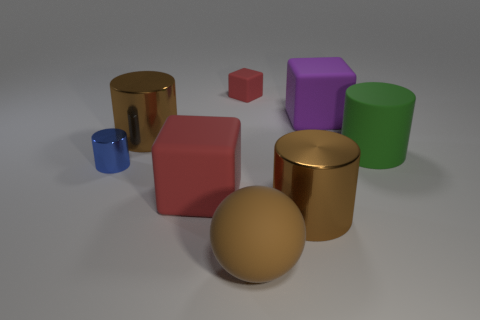Subtract all yellow cylinders. Subtract all brown cubes. How many cylinders are left? 4 Add 1 tiny purple cylinders. How many objects exist? 9 Subtract all blocks. How many objects are left? 5 Add 5 large red metal balls. How many large red metal balls exist? 5 Subtract 0 yellow blocks. How many objects are left? 8 Subtract all large objects. Subtract all large red cubes. How many objects are left? 1 Add 4 small blue metallic things. How many small blue metallic things are left? 5 